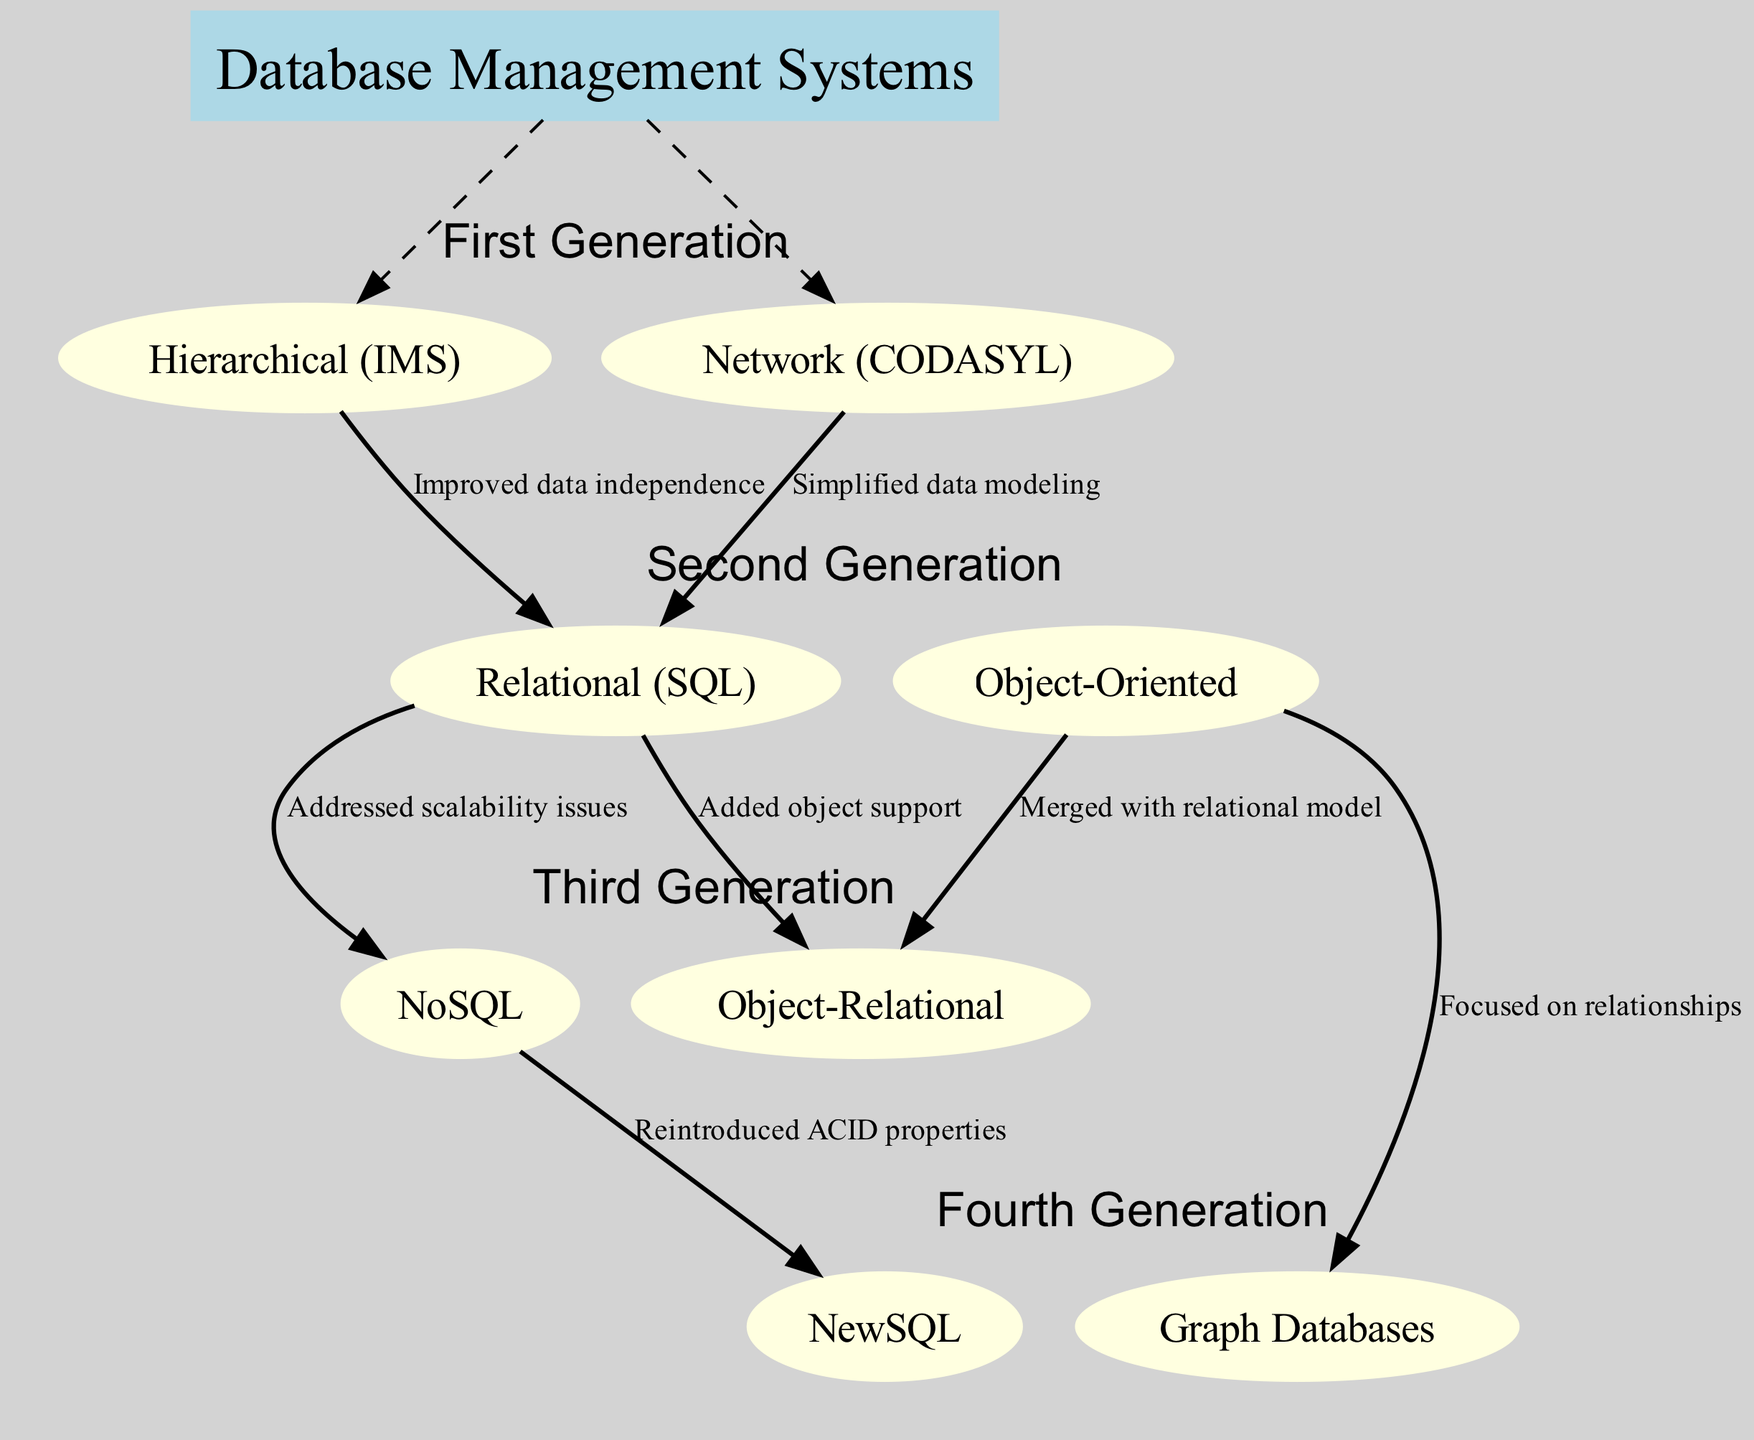What are the two systems in the First Generation? The First Generation has two systems listed: Hierarchical (IMS) and Network (CODASYL). These systems are clearly specified in the "First Generation" section of the diagram.
Answer: Hierarchical (IMS), Network (CODASYL) How many generations are represented in the diagram? The diagram categorizes the database management systems into four distinct generations: First Generation, Second Generation, Third Generation, and Fourth Generation. This information can be counted directly from the “generations” section of the data.
Answer: Four What does Relational (SQL) evolved from? Relational (SQL) has two parent systems: Hierarchical (IMS) and Network (CODASYL), according to the relationships depicted in the diagram. Each relationship explicitly states the parent systems leading to Relational (SQL).
Answer: Hierarchical (IMS), Network (CODASYL) Which system focused on relationships? According to the relationships mentioned, Graph Databases are the systems that specifically focus on relationships. This is denoted in the description provided alongside the edge connecting Object-Oriented to Graph Databases.
Answer: Graph Databases What is the relationship description between NoSQL and NewSQL? The relationship description indicates that NewSQL reintroduced ACID properties after NoSQL addressed scalability issues. To find this, one can follow the edge from NoSQL to NewSQL and read the corresponding label.
Answer: Reintroduced ACID properties Which two systems evolved from Object-Oriented? Object-Relational and Graph Databases both evolved from Object-Oriented. This can be verified by looking at the outgoing edges from the Object-Oriented node in the diagram.
Answer: Object-Relational, Graph Databases What is the evolution from Relational (SQL) to NoSQL? The evolution specifies that NoSQL addressed scalability issues stemming from Relational (SQL). The description accompanying the edge from Relational (SQL) to NoSQL provides this crucial information.
Answer: Addressed scalability issues How many systems are in the Second Generation? The Second Generation includes two systems: Relational (SQL) and Object-Oriented, which can be directly counted from the "Second Generation" section in the diagram.
Answer: Two 